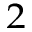<formula> <loc_0><loc_0><loc_500><loc_500>^ { 2 }</formula> 